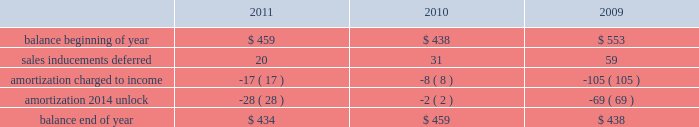The hartford financial services group , inc .
Notes to consolidated financial statements ( continued ) 10 .
Sales inducements accounting policy the company currently offers enhanced crediting rates or bonus payments to contract holders on certain of its individual and group annuity products .
The expense associated with offering a bonus is deferred and amortized over the life of the related contract in a pattern consistent with the amortization of deferred policy acquisition costs .
Amortization expense associated with expenses previously deferred is recorded over the remaining life of the contract .
Consistent with the unlock , the company unlocked the amortization of the sales inducement asset .
See note 7 for more information concerning the unlock .
Changes in deferred sales inducement activity were as follows for the years ended december 31: .
11 .
Reserves for future policy benefits and unpaid losses and loss adjustment expenses life insurance products accounting policy liabilities for future policy benefits are calculated by the net level premium method using interest , withdrawal and mortality assumptions appropriate at the time the policies were issued .
The methods used in determining the liability for unpaid losses and future policy benefits are standard actuarial methods recognized by the american academy of actuaries .
For the tabular reserves , discount rates are based on the company 2019s earned investment yield and the morbidity/mortality tables used are standard industry tables modified to reflect the company 2019s actual experience when appropriate .
In particular , for the company 2019s group disability known claim reserves , the morbidity table for the early durations of claim is based exclusively on the company 2019s experience , incorporating factors such as gender , elimination period and diagnosis .
These reserves are computed such that they are expected to meet the company 2019s future policy obligations .
Future policy benefits are computed at amounts that , with additions from estimated premiums to be received and with interest on such reserves compounded annually at certain assumed rates , are expected to be sufficient to meet the company 2019s policy obligations at their maturities or in the event of an insured 2019s death .
Changes in or deviations from the assumptions used for mortality , morbidity , expected future premiums and interest can significantly affect the company 2019s reserve levels and related future operations and , as such , provisions for adverse deviation are built into the long-tailed liability assumptions .
Liabilities for the company 2019s group life and disability contracts , as well as its individual term life insurance policies , include amounts for unpaid losses and future policy benefits .
Liabilities for unpaid losses include estimates of amounts to fully settle known reported claims , as well as claims related to insured events that the company estimates have been incurred but have not yet been reported .
These reserve estimates are based on known facts and interpretations of circumstances , and consideration of various internal factors including the hartford 2019s experience with similar cases , historical trends involving claim payment patterns , loss payments , pending levels of unpaid claims , loss control programs and product mix .
In addition , the reserve estimates are influenced by consideration of various external factors including court decisions , economic conditions and public attitudes .
The effects of inflation are implicitly considered in the reserving process. .
What was the average sales inducements deferred from 2009 to 2011 in millions? 
Computations: ((59 + (20 + 31)) / 3)
Answer: 36.66667. 